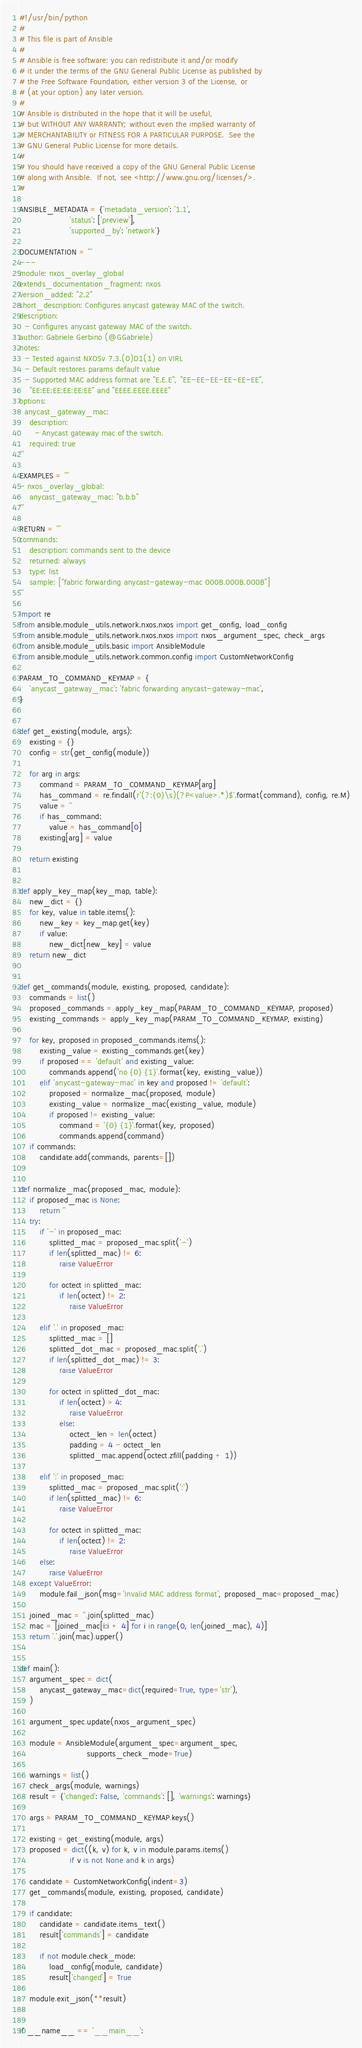Convert code to text. <code><loc_0><loc_0><loc_500><loc_500><_Python_>#!/usr/bin/python
#
# This file is part of Ansible
#
# Ansible is free software: you can redistribute it and/or modify
# it under the terms of the GNU General Public License as published by
# the Free Software Foundation, either version 3 of the License, or
# (at your option) any later version.
#
# Ansible is distributed in the hope that it will be useful,
# but WITHOUT ANY WARRANTY; without even the implied warranty of
# MERCHANTABILITY or FITNESS FOR A PARTICULAR PURPOSE.  See the
# GNU General Public License for more details.
#
# You should have received a copy of the GNU General Public License
# along with Ansible.  If not, see <http://www.gnu.org/licenses/>.
#

ANSIBLE_METADATA = {'metadata_version': '1.1',
                    'status': ['preview'],
                    'supported_by': 'network'}

DOCUMENTATION = '''
---
module: nxos_overlay_global
extends_documentation_fragment: nxos
version_added: "2.2"
short_description: Configures anycast gateway MAC of the switch.
description:
  - Configures anycast gateway MAC of the switch.
author: Gabriele Gerbino (@GGabriele)
notes:
  - Tested against NXOSv 7.3.(0)D1(1) on VIRL
  - Default restores params default value
  - Supported MAC address format are "E.E.E", "EE-EE-EE-EE-EE-EE",
    "EE:EE:EE:EE:EE:EE" and "EEEE.EEEE.EEEE"
options:
  anycast_gateway_mac:
    description:
      - Anycast gateway mac of the switch.
    required: true
'''

EXAMPLES = '''
- nxos_overlay_global:
    anycast_gateway_mac: "b.b.b"
'''

RETURN = '''
commands:
    description: commands sent to the device
    returned: always
    type: list
    sample: ["fabric forwarding anycast-gateway-mac 000B.000B.000B"]
'''

import re
from ansible.module_utils.network.nxos.nxos import get_config, load_config
from ansible.module_utils.network.nxos.nxos import nxos_argument_spec, check_args
from ansible.module_utils.basic import AnsibleModule
from ansible.module_utils.network.common.config import CustomNetworkConfig

PARAM_TO_COMMAND_KEYMAP = {
    'anycast_gateway_mac': 'fabric forwarding anycast-gateway-mac',
}


def get_existing(module, args):
    existing = {}
    config = str(get_config(module))

    for arg in args:
        command = PARAM_TO_COMMAND_KEYMAP[arg]
        has_command = re.findall(r'(?:{0}\s)(?P<value>.*)$'.format(command), config, re.M)
        value = ''
        if has_command:
            value = has_command[0]
        existing[arg] = value

    return existing


def apply_key_map(key_map, table):
    new_dict = {}
    for key, value in table.items():
        new_key = key_map.get(key)
        if value:
            new_dict[new_key] = value
    return new_dict


def get_commands(module, existing, proposed, candidate):
    commands = list()
    proposed_commands = apply_key_map(PARAM_TO_COMMAND_KEYMAP, proposed)
    existing_commands = apply_key_map(PARAM_TO_COMMAND_KEYMAP, existing)

    for key, proposed in proposed_commands.items():
        existing_value = existing_commands.get(key)
        if proposed == 'default' and existing_value:
            commands.append('no {0} {1}'.format(key, existing_value))
        elif 'anycast-gateway-mac' in key and proposed != 'default':
            proposed = normalize_mac(proposed, module)
            existing_value = normalize_mac(existing_value, module)
            if proposed != existing_value:
                command = '{0} {1}'.format(key, proposed)
                commands.append(command)
    if commands:
        candidate.add(commands, parents=[])


def normalize_mac(proposed_mac, module):
    if proposed_mac is None:
        return ''
    try:
        if '-' in proposed_mac:
            splitted_mac = proposed_mac.split('-')
            if len(splitted_mac) != 6:
                raise ValueError

            for octect in splitted_mac:
                if len(octect) != 2:
                    raise ValueError

        elif '.' in proposed_mac:
            splitted_mac = []
            splitted_dot_mac = proposed_mac.split('.')
            if len(splitted_dot_mac) != 3:
                raise ValueError

            for octect in splitted_dot_mac:
                if len(octect) > 4:
                    raise ValueError
                else:
                    octect_len = len(octect)
                    padding = 4 - octect_len
                    splitted_mac.append(octect.zfill(padding + 1))

        elif ':' in proposed_mac:
            splitted_mac = proposed_mac.split(':')
            if len(splitted_mac) != 6:
                raise ValueError

            for octect in splitted_mac:
                if len(octect) != 2:
                    raise ValueError
        else:
            raise ValueError
    except ValueError:
        module.fail_json(msg='Invalid MAC address format', proposed_mac=proposed_mac)

    joined_mac = ''.join(splitted_mac)
    mac = [joined_mac[i:i + 4] for i in range(0, len(joined_mac), 4)]
    return '.'.join(mac).upper()


def main():
    argument_spec = dict(
        anycast_gateway_mac=dict(required=True, type='str'),
    )

    argument_spec.update(nxos_argument_spec)

    module = AnsibleModule(argument_spec=argument_spec,
                           supports_check_mode=True)

    warnings = list()
    check_args(module, warnings)
    result = {'changed': False, 'commands': [], 'warnings': warnings}

    args = PARAM_TO_COMMAND_KEYMAP.keys()

    existing = get_existing(module, args)
    proposed = dict((k, v) for k, v in module.params.items()
                    if v is not None and k in args)

    candidate = CustomNetworkConfig(indent=3)
    get_commands(module, existing, proposed, candidate)

    if candidate:
        candidate = candidate.items_text()
        result['commands'] = candidate

        if not module.check_mode:
            load_config(module, candidate)
            result['changed'] = True

    module.exit_json(**result)


if __name__ == '__main__':</code> 